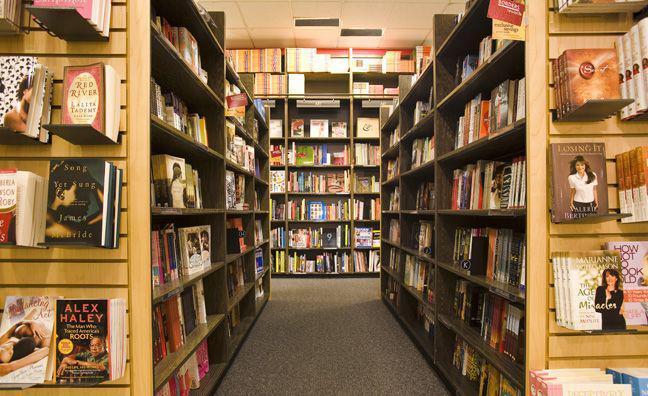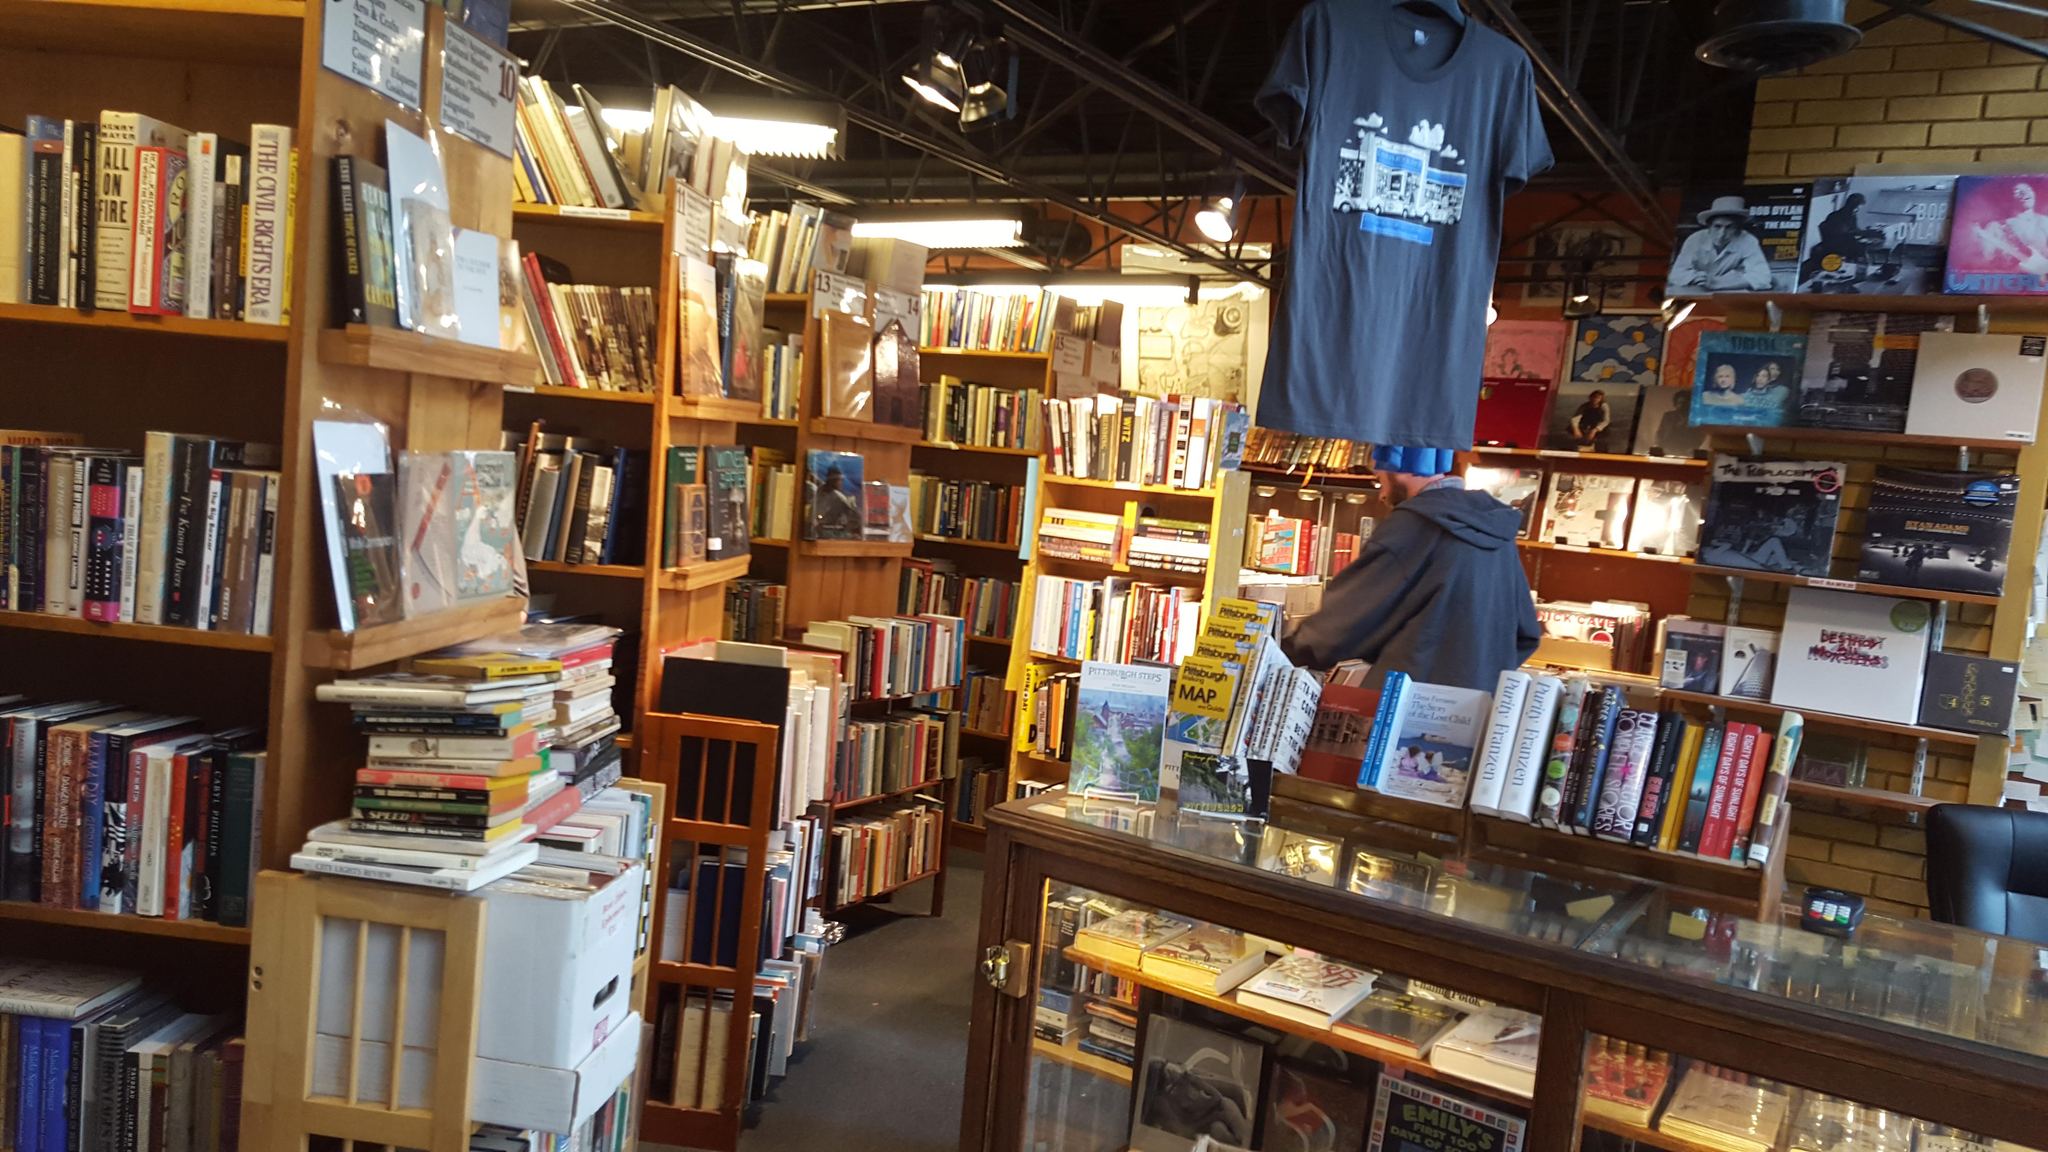The first image is the image on the left, the second image is the image on the right. Given the left and right images, does the statement "One image is straight down an uncluttered, carpeted aisle with books shelved on both sides." hold true? Answer yes or no. Yes. 